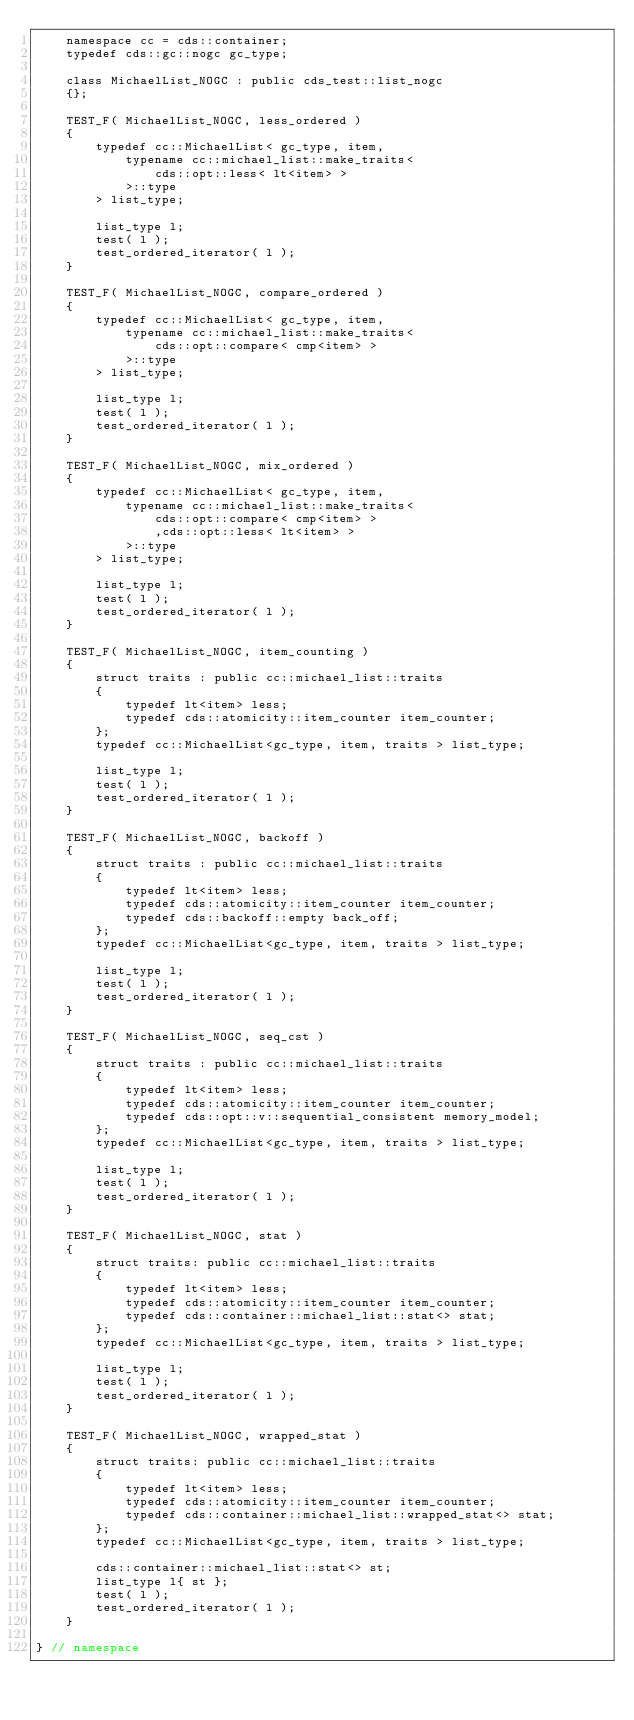<code> <loc_0><loc_0><loc_500><loc_500><_C++_>    namespace cc = cds::container;
    typedef cds::gc::nogc gc_type;

    class MichaelList_NOGC : public cds_test::list_nogc
    {};

    TEST_F( MichaelList_NOGC, less_ordered )
    {
        typedef cc::MichaelList< gc_type, item,
            typename cc::michael_list::make_traits<
                cds::opt::less< lt<item> >
            >::type
        > list_type;

        list_type l;
        test( l );
        test_ordered_iterator( l );
    }

    TEST_F( MichaelList_NOGC, compare_ordered )
    {
        typedef cc::MichaelList< gc_type, item,
            typename cc::michael_list::make_traits<
                cds::opt::compare< cmp<item> >
            >::type
        > list_type;

        list_type l;
        test( l );
        test_ordered_iterator( l );
    }

    TEST_F( MichaelList_NOGC, mix_ordered )
    {
        typedef cc::MichaelList< gc_type, item,
            typename cc::michael_list::make_traits<
                cds::opt::compare< cmp<item> >
                ,cds::opt::less< lt<item> >
            >::type
        > list_type;

        list_type l;
        test( l );
        test_ordered_iterator( l );
    }

    TEST_F( MichaelList_NOGC, item_counting )
    {
        struct traits : public cc::michael_list::traits
        {
            typedef lt<item> less;
            typedef cds::atomicity::item_counter item_counter;
        };
        typedef cc::MichaelList<gc_type, item, traits > list_type;

        list_type l;
        test( l );
        test_ordered_iterator( l );
    }

    TEST_F( MichaelList_NOGC, backoff )
    {
        struct traits : public cc::michael_list::traits
        {
            typedef lt<item> less;
            typedef cds::atomicity::item_counter item_counter;
            typedef cds::backoff::empty back_off;
        };
        typedef cc::MichaelList<gc_type, item, traits > list_type;

        list_type l;
        test( l );
        test_ordered_iterator( l );
    }

    TEST_F( MichaelList_NOGC, seq_cst )
    {
        struct traits : public cc::michael_list::traits
        {
            typedef lt<item> less;
            typedef cds::atomicity::item_counter item_counter;
            typedef cds::opt::v::sequential_consistent memory_model;
        };
        typedef cc::MichaelList<gc_type, item, traits > list_type;

        list_type l;
        test( l );
        test_ordered_iterator( l );
    }

    TEST_F( MichaelList_NOGC, stat )
    {
        struct traits: public cc::michael_list::traits
        {
            typedef lt<item> less;
            typedef cds::atomicity::item_counter item_counter;
            typedef cds::container::michael_list::stat<> stat;
        };
        typedef cc::MichaelList<gc_type, item, traits > list_type;

        list_type l;
        test( l );
        test_ordered_iterator( l );
    }

    TEST_F( MichaelList_NOGC, wrapped_stat )
    {
        struct traits: public cc::michael_list::traits
        {
            typedef lt<item> less;
            typedef cds::atomicity::item_counter item_counter;
            typedef cds::container::michael_list::wrapped_stat<> stat;
        };
        typedef cc::MichaelList<gc_type, item, traits > list_type;

        cds::container::michael_list::stat<> st;
        list_type l{ st };
        test( l );
        test_ordered_iterator( l );
    }

} // namespace
</code> 